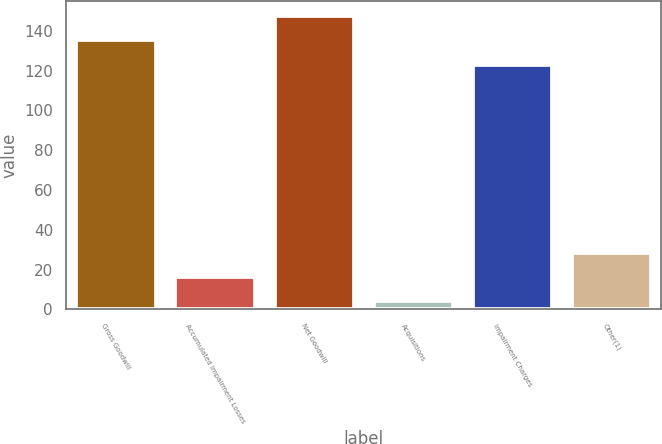Convert chart to OTSL. <chart><loc_0><loc_0><loc_500><loc_500><bar_chart><fcel>Gross Goodwill<fcel>Accumulated Impairment Losses<fcel>Net Goodwill<fcel>Acquisitions<fcel>Impairment Charges<fcel>Other(1)<nl><fcel>135.2<fcel>16.2<fcel>147.4<fcel>4<fcel>123<fcel>28.4<nl></chart> 